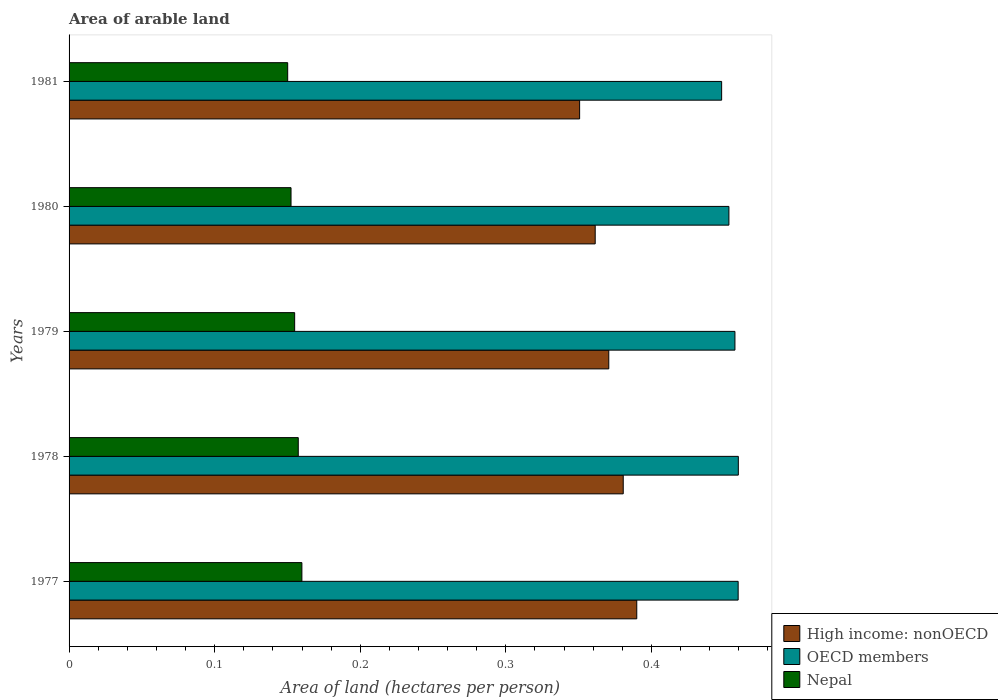How many different coloured bars are there?
Offer a terse response. 3. Are the number of bars on each tick of the Y-axis equal?
Offer a very short reply. Yes. What is the label of the 4th group of bars from the top?
Offer a very short reply. 1978. In how many cases, is the number of bars for a given year not equal to the number of legend labels?
Provide a short and direct response. 0. What is the total arable land in Nepal in 1980?
Provide a succinct answer. 0.15. Across all years, what is the maximum total arable land in Nepal?
Your answer should be very brief. 0.16. Across all years, what is the minimum total arable land in High income: nonOECD?
Your answer should be compact. 0.35. In which year was the total arable land in Nepal maximum?
Provide a short and direct response. 1977. In which year was the total arable land in OECD members minimum?
Provide a short and direct response. 1981. What is the total total arable land in OECD members in the graph?
Your answer should be very brief. 2.28. What is the difference between the total arable land in High income: nonOECD in 1978 and that in 1980?
Your response must be concise. 0.02. What is the difference between the total arable land in OECD members in 1978 and the total arable land in High income: nonOECD in 1977?
Keep it short and to the point. 0.07. What is the average total arable land in High income: nonOECD per year?
Offer a very short reply. 0.37. In the year 1981, what is the difference between the total arable land in Nepal and total arable land in High income: nonOECD?
Ensure brevity in your answer.  -0.2. What is the ratio of the total arable land in OECD members in 1977 to that in 1978?
Provide a short and direct response. 1. Is the difference between the total arable land in Nepal in 1977 and 1978 greater than the difference between the total arable land in High income: nonOECD in 1977 and 1978?
Provide a succinct answer. No. What is the difference between the highest and the second highest total arable land in High income: nonOECD?
Your response must be concise. 0.01. What is the difference between the highest and the lowest total arable land in Nepal?
Provide a succinct answer. 0.01. In how many years, is the total arable land in Nepal greater than the average total arable land in Nepal taken over all years?
Provide a succinct answer. 2. What does the 3rd bar from the top in 1979 represents?
Make the answer very short. High income: nonOECD. What does the 1st bar from the bottom in 1977 represents?
Offer a very short reply. High income: nonOECD. Are all the bars in the graph horizontal?
Give a very brief answer. Yes. How many years are there in the graph?
Your response must be concise. 5. What is the difference between two consecutive major ticks on the X-axis?
Offer a terse response. 0.1. Does the graph contain grids?
Your answer should be compact. No. How many legend labels are there?
Your response must be concise. 3. What is the title of the graph?
Provide a succinct answer. Area of arable land. What is the label or title of the X-axis?
Provide a succinct answer. Area of land (hectares per person). What is the Area of land (hectares per person) in High income: nonOECD in 1977?
Provide a short and direct response. 0.39. What is the Area of land (hectares per person) of OECD members in 1977?
Give a very brief answer. 0.46. What is the Area of land (hectares per person) in Nepal in 1977?
Keep it short and to the point. 0.16. What is the Area of land (hectares per person) in High income: nonOECD in 1978?
Provide a short and direct response. 0.38. What is the Area of land (hectares per person) in OECD members in 1978?
Ensure brevity in your answer.  0.46. What is the Area of land (hectares per person) in Nepal in 1978?
Give a very brief answer. 0.16. What is the Area of land (hectares per person) of High income: nonOECD in 1979?
Your answer should be compact. 0.37. What is the Area of land (hectares per person) in OECD members in 1979?
Your response must be concise. 0.46. What is the Area of land (hectares per person) in Nepal in 1979?
Offer a very short reply. 0.15. What is the Area of land (hectares per person) of High income: nonOECD in 1980?
Offer a terse response. 0.36. What is the Area of land (hectares per person) in OECD members in 1980?
Offer a very short reply. 0.45. What is the Area of land (hectares per person) of Nepal in 1980?
Your answer should be compact. 0.15. What is the Area of land (hectares per person) in High income: nonOECD in 1981?
Ensure brevity in your answer.  0.35. What is the Area of land (hectares per person) in OECD members in 1981?
Give a very brief answer. 0.45. What is the Area of land (hectares per person) in Nepal in 1981?
Provide a short and direct response. 0.15. Across all years, what is the maximum Area of land (hectares per person) in High income: nonOECD?
Your answer should be compact. 0.39. Across all years, what is the maximum Area of land (hectares per person) in OECD members?
Provide a short and direct response. 0.46. Across all years, what is the maximum Area of land (hectares per person) of Nepal?
Offer a terse response. 0.16. Across all years, what is the minimum Area of land (hectares per person) in High income: nonOECD?
Your answer should be very brief. 0.35. Across all years, what is the minimum Area of land (hectares per person) in OECD members?
Give a very brief answer. 0.45. Across all years, what is the minimum Area of land (hectares per person) of Nepal?
Provide a succinct answer. 0.15. What is the total Area of land (hectares per person) in High income: nonOECD in the graph?
Provide a short and direct response. 1.85. What is the total Area of land (hectares per person) in OECD members in the graph?
Keep it short and to the point. 2.28. What is the total Area of land (hectares per person) of Nepal in the graph?
Give a very brief answer. 0.77. What is the difference between the Area of land (hectares per person) in High income: nonOECD in 1977 and that in 1978?
Give a very brief answer. 0.01. What is the difference between the Area of land (hectares per person) in OECD members in 1977 and that in 1978?
Keep it short and to the point. -0. What is the difference between the Area of land (hectares per person) of Nepal in 1977 and that in 1978?
Ensure brevity in your answer.  0. What is the difference between the Area of land (hectares per person) in High income: nonOECD in 1977 and that in 1979?
Your response must be concise. 0.02. What is the difference between the Area of land (hectares per person) of OECD members in 1977 and that in 1979?
Ensure brevity in your answer.  0. What is the difference between the Area of land (hectares per person) of Nepal in 1977 and that in 1979?
Your answer should be compact. 0.01. What is the difference between the Area of land (hectares per person) in High income: nonOECD in 1977 and that in 1980?
Keep it short and to the point. 0.03. What is the difference between the Area of land (hectares per person) of OECD members in 1977 and that in 1980?
Ensure brevity in your answer.  0.01. What is the difference between the Area of land (hectares per person) in Nepal in 1977 and that in 1980?
Offer a terse response. 0.01. What is the difference between the Area of land (hectares per person) of High income: nonOECD in 1977 and that in 1981?
Your response must be concise. 0.04. What is the difference between the Area of land (hectares per person) in OECD members in 1977 and that in 1981?
Your answer should be compact. 0.01. What is the difference between the Area of land (hectares per person) in Nepal in 1977 and that in 1981?
Keep it short and to the point. 0.01. What is the difference between the Area of land (hectares per person) of High income: nonOECD in 1978 and that in 1979?
Your answer should be very brief. 0.01. What is the difference between the Area of land (hectares per person) in OECD members in 1978 and that in 1979?
Your answer should be compact. 0. What is the difference between the Area of land (hectares per person) of Nepal in 1978 and that in 1979?
Provide a succinct answer. 0. What is the difference between the Area of land (hectares per person) in High income: nonOECD in 1978 and that in 1980?
Give a very brief answer. 0.02. What is the difference between the Area of land (hectares per person) in OECD members in 1978 and that in 1980?
Your response must be concise. 0.01. What is the difference between the Area of land (hectares per person) of Nepal in 1978 and that in 1980?
Your answer should be compact. 0.01. What is the difference between the Area of land (hectares per person) in High income: nonOECD in 1978 and that in 1981?
Your answer should be very brief. 0.03. What is the difference between the Area of land (hectares per person) in OECD members in 1978 and that in 1981?
Offer a terse response. 0.01. What is the difference between the Area of land (hectares per person) of Nepal in 1978 and that in 1981?
Your answer should be very brief. 0.01. What is the difference between the Area of land (hectares per person) in High income: nonOECD in 1979 and that in 1980?
Ensure brevity in your answer.  0.01. What is the difference between the Area of land (hectares per person) in OECD members in 1979 and that in 1980?
Keep it short and to the point. 0. What is the difference between the Area of land (hectares per person) in Nepal in 1979 and that in 1980?
Provide a succinct answer. 0. What is the difference between the Area of land (hectares per person) of OECD members in 1979 and that in 1981?
Your response must be concise. 0.01. What is the difference between the Area of land (hectares per person) of Nepal in 1979 and that in 1981?
Your answer should be compact. 0. What is the difference between the Area of land (hectares per person) of High income: nonOECD in 1980 and that in 1981?
Provide a succinct answer. 0.01. What is the difference between the Area of land (hectares per person) in OECD members in 1980 and that in 1981?
Offer a terse response. 0.01. What is the difference between the Area of land (hectares per person) in Nepal in 1980 and that in 1981?
Offer a very short reply. 0. What is the difference between the Area of land (hectares per person) in High income: nonOECD in 1977 and the Area of land (hectares per person) in OECD members in 1978?
Keep it short and to the point. -0.07. What is the difference between the Area of land (hectares per person) in High income: nonOECD in 1977 and the Area of land (hectares per person) in Nepal in 1978?
Give a very brief answer. 0.23. What is the difference between the Area of land (hectares per person) in OECD members in 1977 and the Area of land (hectares per person) in Nepal in 1978?
Your answer should be very brief. 0.3. What is the difference between the Area of land (hectares per person) in High income: nonOECD in 1977 and the Area of land (hectares per person) in OECD members in 1979?
Your answer should be very brief. -0.07. What is the difference between the Area of land (hectares per person) in High income: nonOECD in 1977 and the Area of land (hectares per person) in Nepal in 1979?
Make the answer very short. 0.23. What is the difference between the Area of land (hectares per person) in OECD members in 1977 and the Area of land (hectares per person) in Nepal in 1979?
Make the answer very short. 0.3. What is the difference between the Area of land (hectares per person) in High income: nonOECD in 1977 and the Area of land (hectares per person) in OECD members in 1980?
Your answer should be compact. -0.06. What is the difference between the Area of land (hectares per person) in High income: nonOECD in 1977 and the Area of land (hectares per person) in Nepal in 1980?
Ensure brevity in your answer.  0.24. What is the difference between the Area of land (hectares per person) in OECD members in 1977 and the Area of land (hectares per person) in Nepal in 1980?
Your answer should be compact. 0.31. What is the difference between the Area of land (hectares per person) in High income: nonOECD in 1977 and the Area of land (hectares per person) in OECD members in 1981?
Give a very brief answer. -0.06. What is the difference between the Area of land (hectares per person) in High income: nonOECD in 1977 and the Area of land (hectares per person) in Nepal in 1981?
Your response must be concise. 0.24. What is the difference between the Area of land (hectares per person) in OECD members in 1977 and the Area of land (hectares per person) in Nepal in 1981?
Provide a succinct answer. 0.31. What is the difference between the Area of land (hectares per person) in High income: nonOECD in 1978 and the Area of land (hectares per person) in OECD members in 1979?
Offer a very short reply. -0.08. What is the difference between the Area of land (hectares per person) in High income: nonOECD in 1978 and the Area of land (hectares per person) in Nepal in 1979?
Your response must be concise. 0.23. What is the difference between the Area of land (hectares per person) of OECD members in 1978 and the Area of land (hectares per person) of Nepal in 1979?
Offer a terse response. 0.3. What is the difference between the Area of land (hectares per person) in High income: nonOECD in 1978 and the Area of land (hectares per person) in OECD members in 1980?
Make the answer very short. -0.07. What is the difference between the Area of land (hectares per person) in High income: nonOECD in 1978 and the Area of land (hectares per person) in Nepal in 1980?
Your response must be concise. 0.23. What is the difference between the Area of land (hectares per person) in OECD members in 1978 and the Area of land (hectares per person) in Nepal in 1980?
Ensure brevity in your answer.  0.31. What is the difference between the Area of land (hectares per person) in High income: nonOECD in 1978 and the Area of land (hectares per person) in OECD members in 1981?
Your answer should be very brief. -0.07. What is the difference between the Area of land (hectares per person) of High income: nonOECD in 1978 and the Area of land (hectares per person) of Nepal in 1981?
Your answer should be compact. 0.23. What is the difference between the Area of land (hectares per person) of OECD members in 1978 and the Area of land (hectares per person) of Nepal in 1981?
Keep it short and to the point. 0.31. What is the difference between the Area of land (hectares per person) in High income: nonOECD in 1979 and the Area of land (hectares per person) in OECD members in 1980?
Keep it short and to the point. -0.08. What is the difference between the Area of land (hectares per person) of High income: nonOECD in 1979 and the Area of land (hectares per person) of Nepal in 1980?
Provide a succinct answer. 0.22. What is the difference between the Area of land (hectares per person) in OECD members in 1979 and the Area of land (hectares per person) in Nepal in 1980?
Offer a terse response. 0.3. What is the difference between the Area of land (hectares per person) of High income: nonOECD in 1979 and the Area of land (hectares per person) of OECD members in 1981?
Your response must be concise. -0.08. What is the difference between the Area of land (hectares per person) of High income: nonOECD in 1979 and the Area of land (hectares per person) of Nepal in 1981?
Your answer should be very brief. 0.22. What is the difference between the Area of land (hectares per person) of OECD members in 1979 and the Area of land (hectares per person) of Nepal in 1981?
Make the answer very short. 0.31. What is the difference between the Area of land (hectares per person) of High income: nonOECD in 1980 and the Area of land (hectares per person) of OECD members in 1981?
Offer a very short reply. -0.09. What is the difference between the Area of land (hectares per person) of High income: nonOECD in 1980 and the Area of land (hectares per person) of Nepal in 1981?
Offer a terse response. 0.21. What is the difference between the Area of land (hectares per person) in OECD members in 1980 and the Area of land (hectares per person) in Nepal in 1981?
Ensure brevity in your answer.  0.3. What is the average Area of land (hectares per person) of High income: nonOECD per year?
Offer a very short reply. 0.37. What is the average Area of land (hectares per person) in OECD members per year?
Give a very brief answer. 0.46. What is the average Area of land (hectares per person) of Nepal per year?
Give a very brief answer. 0.15. In the year 1977, what is the difference between the Area of land (hectares per person) of High income: nonOECD and Area of land (hectares per person) of OECD members?
Offer a terse response. -0.07. In the year 1977, what is the difference between the Area of land (hectares per person) of High income: nonOECD and Area of land (hectares per person) of Nepal?
Your answer should be very brief. 0.23. In the year 1977, what is the difference between the Area of land (hectares per person) in OECD members and Area of land (hectares per person) in Nepal?
Provide a succinct answer. 0.3. In the year 1978, what is the difference between the Area of land (hectares per person) of High income: nonOECD and Area of land (hectares per person) of OECD members?
Provide a succinct answer. -0.08. In the year 1978, what is the difference between the Area of land (hectares per person) of High income: nonOECD and Area of land (hectares per person) of Nepal?
Keep it short and to the point. 0.22. In the year 1978, what is the difference between the Area of land (hectares per person) of OECD members and Area of land (hectares per person) of Nepal?
Give a very brief answer. 0.3. In the year 1979, what is the difference between the Area of land (hectares per person) of High income: nonOECD and Area of land (hectares per person) of OECD members?
Give a very brief answer. -0.09. In the year 1979, what is the difference between the Area of land (hectares per person) of High income: nonOECD and Area of land (hectares per person) of Nepal?
Keep it short and to the point. 0.22. In the year 1979, what is the difference between the Area of land (hectares per person) of OECD members and Area of land (hectares per person) of Nepal?
Ensure brevity in your answer.  0.3. In the year 1980, what is the difference between the Area of land (hectares per person) in High income: nonOECD and Area of land (hectares per person) in OECD members?
Offer a terse response. -0.09. In the year 1980, what is the difference between the Area of land (hectares per person) of High income: nonOECD and Area of land (hectares per person) of Nepal?
Offer a terse response. 0.21. In the year 1980, what is the difference between the Area of land (hectares per person) in OECD members and Area of land (hectares per person) in Nepal?
Provide a succinct answer. 0.3. In the year 1981, what is the difference between the Area of land (hectares per person) in High income: nonOECD and Area of land (hectares per person) in OECD members?
Offer a very short reply. -0.1. In the year 1981, what is the difference between the Area of land (hectares per person) in High income: nonOECD and Area of land (hectares per person) in Nepal?
Give a very brief answer. 0.2. In the year 1981, what is the difference between the Area of land (hectares per person) of OECD members and Area of land (hectares per person) of Nepal?
Your response must be concise. 0.3. What is the ratio of the Area of land (hectares per person) in High income: nonOECD in 1977 to that in 1978?
Provide a short and direct response. 1.02. What is the ratio of the Area of land (hectares per person) of OECD members in 1977 to that in 1978?
Offer a very short reply. 1. What is the ratio of the Area of land (hectares per person) of Nepal in 1977 to that in 1978?
Give a very brief answer. 1.02. What is the ratio of the Area of land (hectares per person) of High income: nonOECD in 1977 to that in 1979?
Your answer should be very brief. 1.05. What is the ratio of the Area of land (hectares per person) of OECD members in 1977 to that in 1979?
Make the answer very short. 1. What is the ratio of the Area of land (hectares per person) of Nepal in 1977 to that in 1979?
Make the answer very short. 1.03. What is the ratio of the Area of land (hectares per person) in High income: nonOECD in 1977 to that in 1980?
Give a very brief answer. 1.08. What is the ratio of the Area of land (hectares per person) of OECD members in 1977 to that in 1980?
Provide a short and direct response. 1.01. What is the ratio of the Area of land (hectares per person) in Nepal in 1977 to that in 1980?
Provide a short and direct response. 1.05. What is the ratio of the Area of land (hectares per person) in High income: nonOECD in 1977 to that in 1981?
Give a very brief answer. 1.11. What is the ratio of the Area of land (hectares per person) in OECD members in 1977 to that in 1981?
Offer a terse response. 1.03. What is the ratio of the Area of land (hectares per person) in Nepal in 1977 to that in 1981?
Your answer should be compact. 1.06. What is the ratio of the Area of land (hectares per person) in High income: nonOECD in 1978 to that in 1979?
Keep it short and to the point. 1.03. What is the ratio of the Area of land (hectares per person) in Nepal in 1978 to that in 1979?
Make the answer very short. 1.02. What is the ratio of the Area of land (hectares per person) of High income: nonOECD in 1978 to that in 1980?
Make the answer very short. 1.05. What is the ratio of the Area of land (hectares per person) in OECD members in 1978 to that in 1980?
Ensure brevity in your answer.  1.01. What is the ratio of the Area of land (hectares per person) of Nepal in 1978 to that in 1980?
Provide a short and direct response. 1.03. What is the ratio of the Area of land (hectares per person) of High income: nonOECD in 1978 to that in 1981?
Your answer should be very brief. 1.09. What is the ratio of the Area of land (hectares per person) of OECD members in 1978 to that in 1981?
Provide a short and direct response. 1.03. What is the ratio of the Area of land (hectares per person) in Nepal in 1978 to that in 1981?
Your answer should be compact. 1.05. What is the ratio of the Area of land (hectares per person) in High income: nonOECD in 1979 to that in 1980?
Your response must be concise. 1.03. What is the ratio of the Area of land (hectares per person) of OECD members in 1979 to that in 1980?
Ensure brevity in your answer.  1.01. What is the ratio of the Area of land (hectares per person) in Nepal in 1979 to that in 1980?
Offer a very short reply. 1.02. What is the ratio of the Area of land (hectares per person) of High income: nonOECD in 1979 to that in 1981?
Keep it short and to the point. 1.06. What is the ratio of the Area of land (hectares per person) in OECD members in 1979 to that in 1981?
Give a very brief answer. 1.02. What is the ratio of the Area of land (hectares per person) of Nepal in 1979 to that in 1981?
Provide a short and direct response. 1.03. What is the ratio of the Area of land (hectares per person) of High income: nonOECD in 1980 to that in 1981?
Ensure brevity in your answer.  1.03. What is the ratio of the Area of land (hectares per person) in OECD members in 1980 to that in 1981?
Your answer should be very brief. 1.01. What is the ratio of the Area of land (hectares per person) in Nepal in 1980 to that in 1981?
Offer a terse response. 1.02. What is the difference between the highest and the second highest Area of land (hectares per person) of High income: nonOECD?
Give a very brief answer. 0.01. What is the difference between the highest and the second highest Area of land (hectares per person) of Nepal?
Your answer should be compact. 0. What is the difference between the highest and the lowest Area of land (hectares per person) in High income: nonOECD?
Offer a very short reply. 0.04. What is the difference between the highest and the lowest Area of land (hectares per person) in OECD members?
Provide a short and direct response. 0.01. What is the difference between the highest and the lowest Area of land (hectares per person) in Nepal?
Provide a short and direct response. 0.01. 